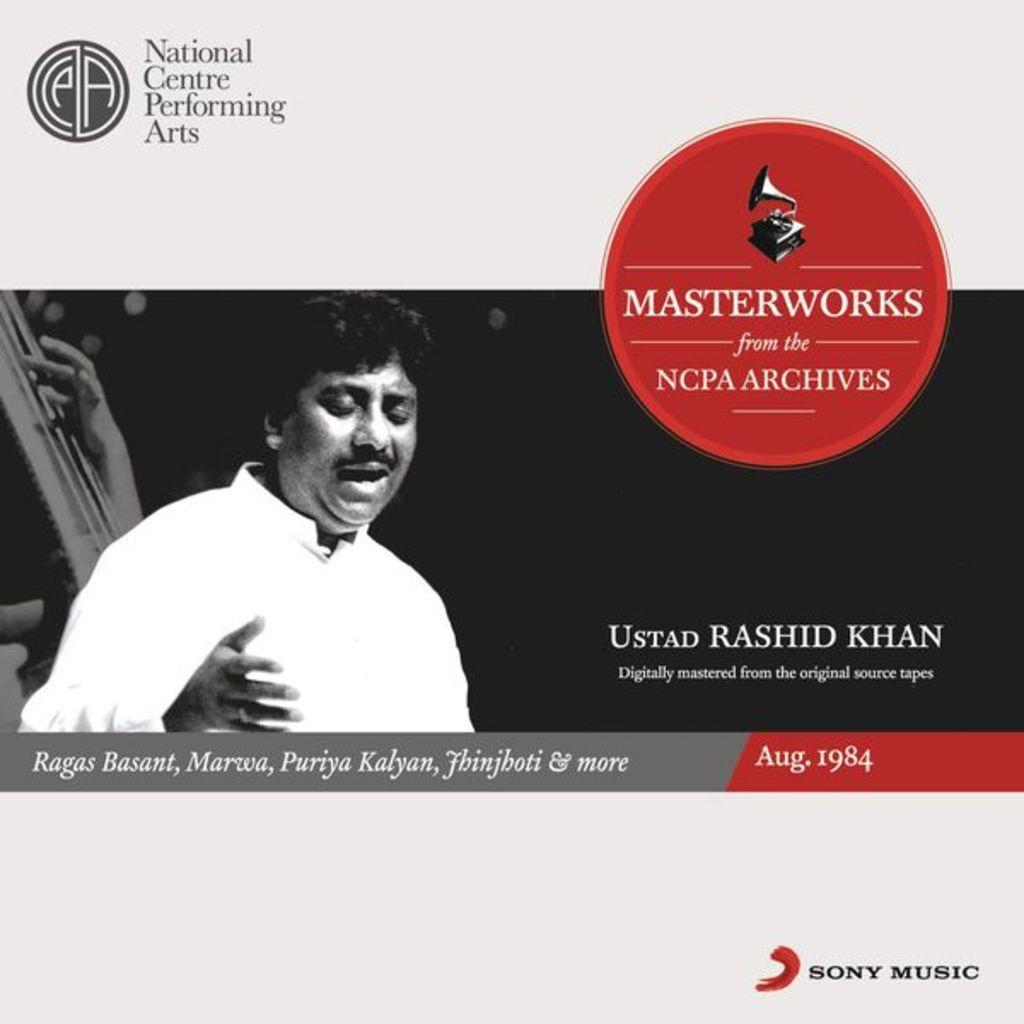In one or two sentences, can you explain what this image depicts? In the picture I can see a black and white photo of a man and some other things. I can also see some logos and something written on the image. 